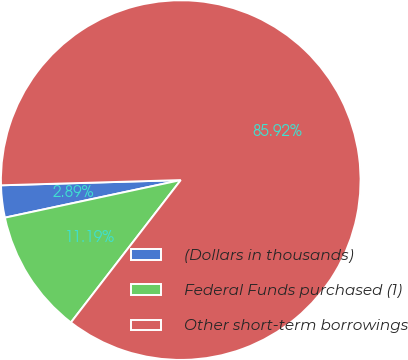<chart> <loc_0><loc_0><loc_500><loc_500><pie_chart><fcel>(Dollars in thousands)<fcel>Federal Funds purchased (1)<fcel>Other short-term borrowings<nl><fcel>2.89%<fcel>11.19%<fcel>85.92%<nl></chart> 